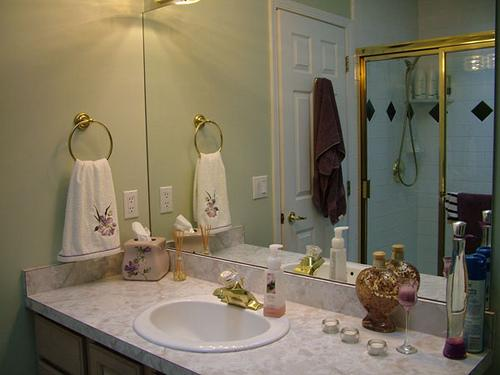What is closest to the place you would go to charge your phone? towel 